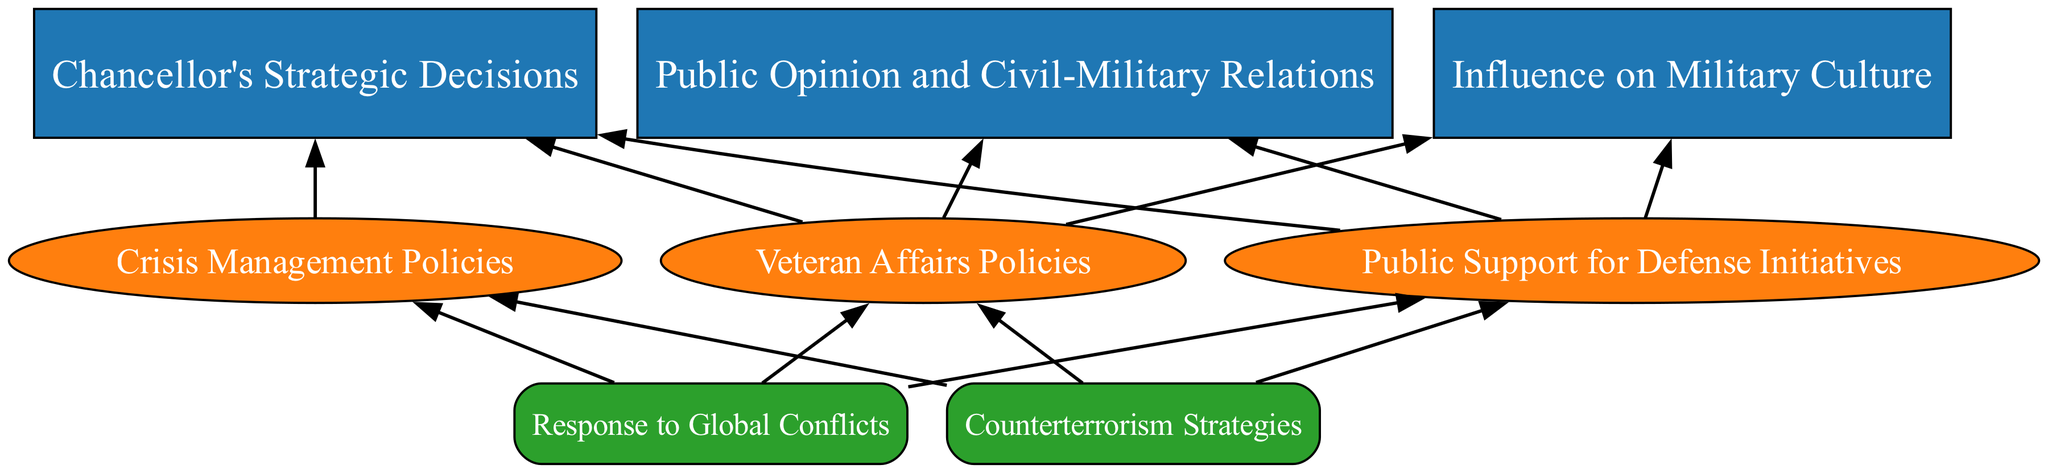What is the top element in the diagram? The top element, which serves as the main idea of the flow chart, is labeled "Chancellor's Strategic Decisions." This can be identified visually as it has no parent element above it.
Answer: Chancellor's Strategic Decisions How many main categories are present in the first level? There are three main categories in the first level under the top element: "Chancellor's Strategic Decisions," "Influence on Military Culture," and "Public Opinion and Civil-Military Relations." These categories can be counted directly from the diagram.
Answer: 3 What is the relationship between "Military Alliances Formation" and "Crisis Management Policies"? "Military Alliances Formation" and "Crisis Management Policies" are both sub-elements under the main element "Chancellor's Strategic Decisions," indicating they are part of the broader strategic decisions made by the Chancellor. This relationship is established through the hierarchical structure of the diagram.
Answer: Sub-elements of Chancellor's Strategic Decisions Which sub-element is associated with improved capacity of the military? The sub-element that focuses on enhanced military capacity is "Modernization of Armed Forces," recognized as a direct component under "Defense Budget Allocation."
Answer: Modernization of Armed Forces How many sub-elements are listed under "Influence on Military Culture"? There are two sub-elements listed under "Influence on Military Culture": "Promotion of Leadership Development" and "Enhancement of Training Programs." This count can be verified by looking at the diagram’s flow from the main category.
Answer: 2 What is the last sub-element of "Defense Budget Allocation"? The last sub-element under "Defense Budget Allocation" is "Modernization of Armed Forces." This can be confirmed by examining the list of sub-elements under the budget allocation category.
Answer: Modernization of Armed Forces What element has the most sub-elements? The element with the most sub-elements is "Chancellor's Strategic Decisions," which contains three sub-elements: "Military Alliances Formation," "Defense Budget Allocation," and "Crisis Management Policies." This can be determined by examining the number of branches originating from this main element.
Answer: Chancellor's Strategic Decisions Which category includes "Veteran Affairs Policies"? "Veteran Affairs Policies" is included in the category "Public Opinion and Civil-Military Relations," as indicated by its placement in the diagram under that specific main category.
Answer: Public Opinion and Civil-Military Relations What is the first sub-element under "Crisis Management Policies"? The first sub-element under "Crisis Management Policies" is "Response to Global Conflicts." This can be identified by looking at the order of the sub-elements listed in that specific category.
Answer: Response to Global Conflicts 